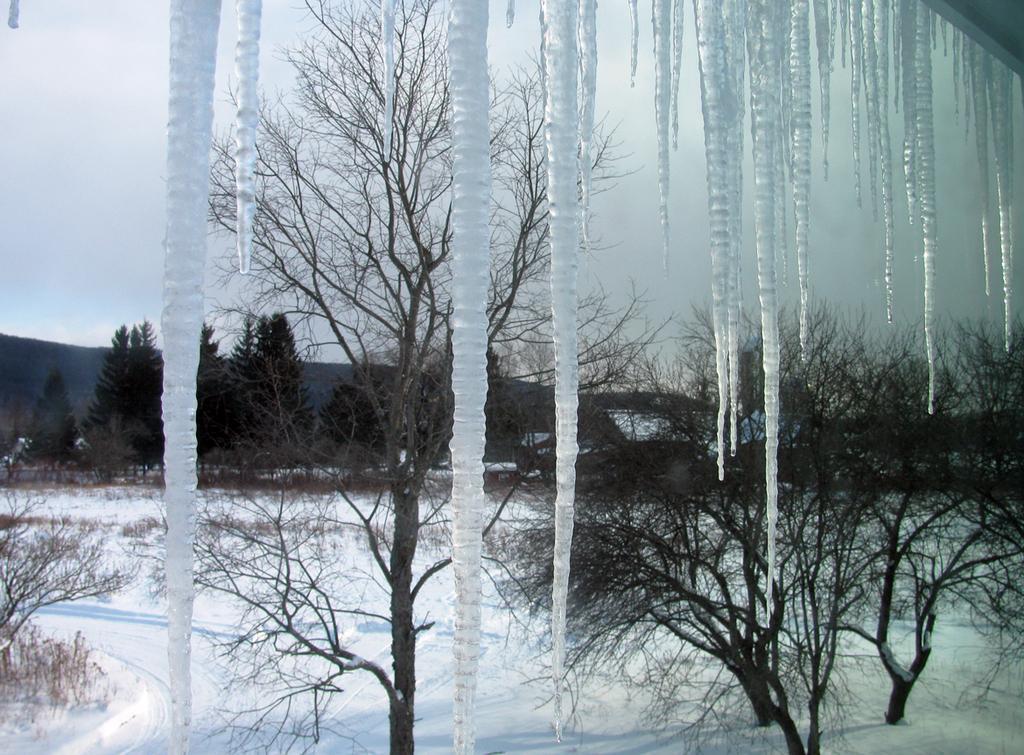In one or two sentences, can you explain what this image depicts? It is image in the center there is snow stand and there are trees. On the ground there is snow. In the background there are trees. 